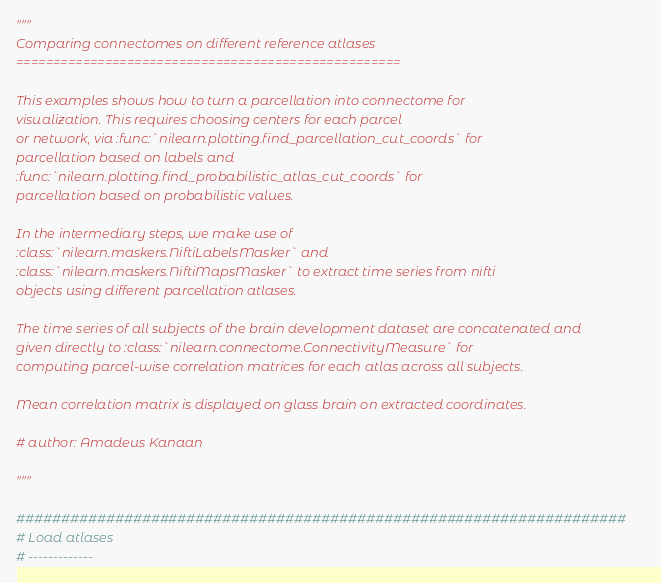Convert code to text. <code><loc_0><loc_0><loc_500><loc_500><_Python_>"""
Comparing connectomes on different reference atlases
====================================================

This examples shows how to turn a parcellation into connectome for
visualization. This requires choosing centers for each parcel
or network, via :func:`nilearn.plotting.find_parcellation_cut_coords` for
parcellation based on labels and
:func:`nilearn.plotting.find_probabilistic_atlas_cut_coords` for
parcellation based on probabilistic values.

In the intermediary steps, we make use of
:class:`nilearn.maskers.NiftiLabelsMasker` and
:class:`nilearn.maskers.NiftiMapsMasker` to extract time series from nifti
objects using different parcellation atlases.

The time series of all subjects of the brain development dataset are concatenated and
given directly to :class:`nilearn.connectome.ConnectivityMeasure` for
computing parcel-wise correlation matrices for each atlas across all subjects.

Mean correlation matrix is displayed on glass brain on extracted coordinates.

# author: Amadeus Kanaan

"""

####################################################################
# Load atlases
# -------------</code> 